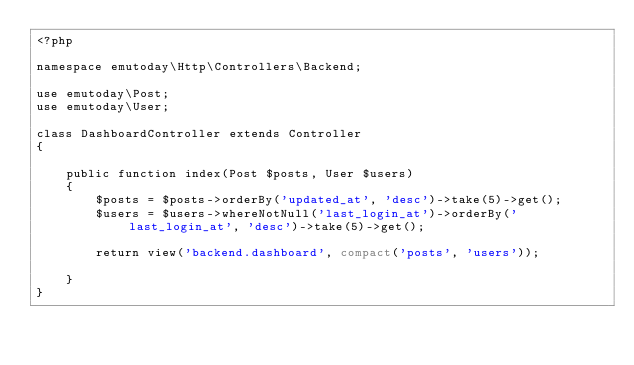<code> <loc_0><loc_0><loc_500><loc_500><_PHP_><?php

namespace emutoday\Http\Controllers\Backend;

use emutoday\Post;
use emutoday\User;

class DashboardController extends Controller
{

    public function index(Post $posts, User $users)
    {
        $posts = $posts->orderBy('updated_at', 'desc')->take(5)->get();
        $users = $users->whereNotNull('last_login_at')->orderBy('last_login_at', 'desc')->take(5)->get();

        return view('backend.dashboard', compact('posts', 'users'));

    }
}
</code> 